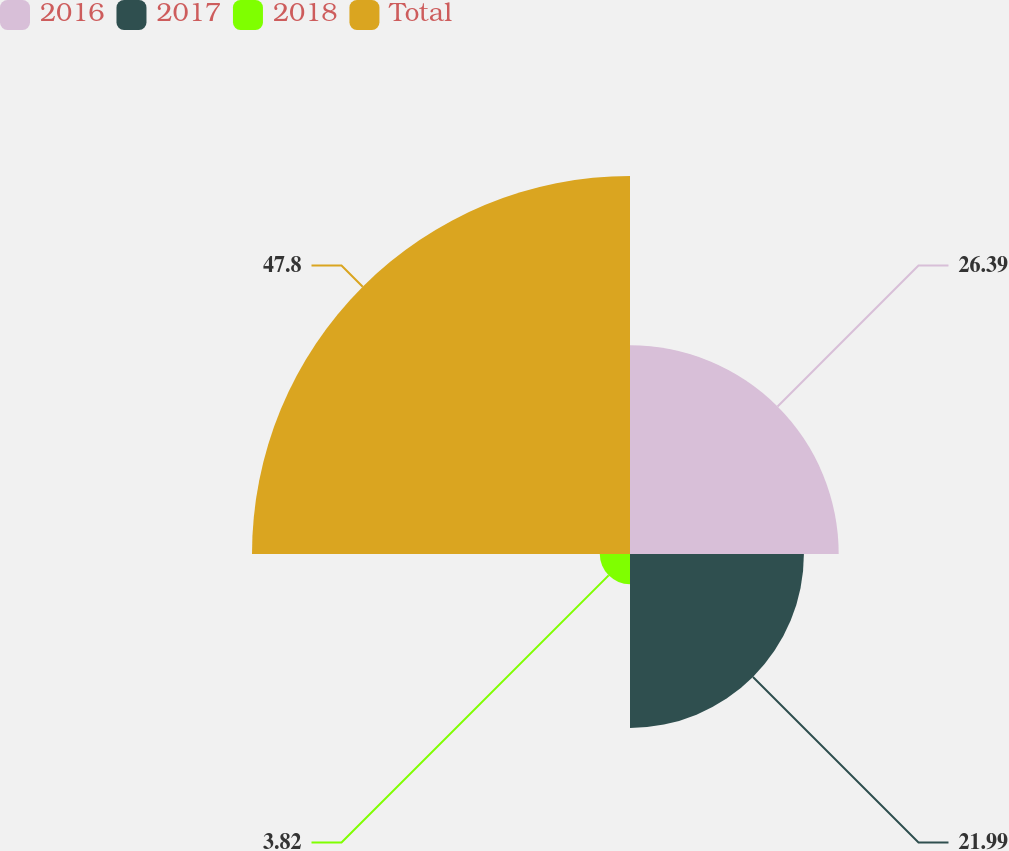Convert chart to OTSL. <chart><loc_0><loc_0><loc_500><loc_500><pie_chart><fcel>2016<fcel>2017<fcel>2018<fcel>Total<nl><fcel>26.39%<fcel>21.99%<fcel>3.82%<fcel>47.8%<nl></chart> 